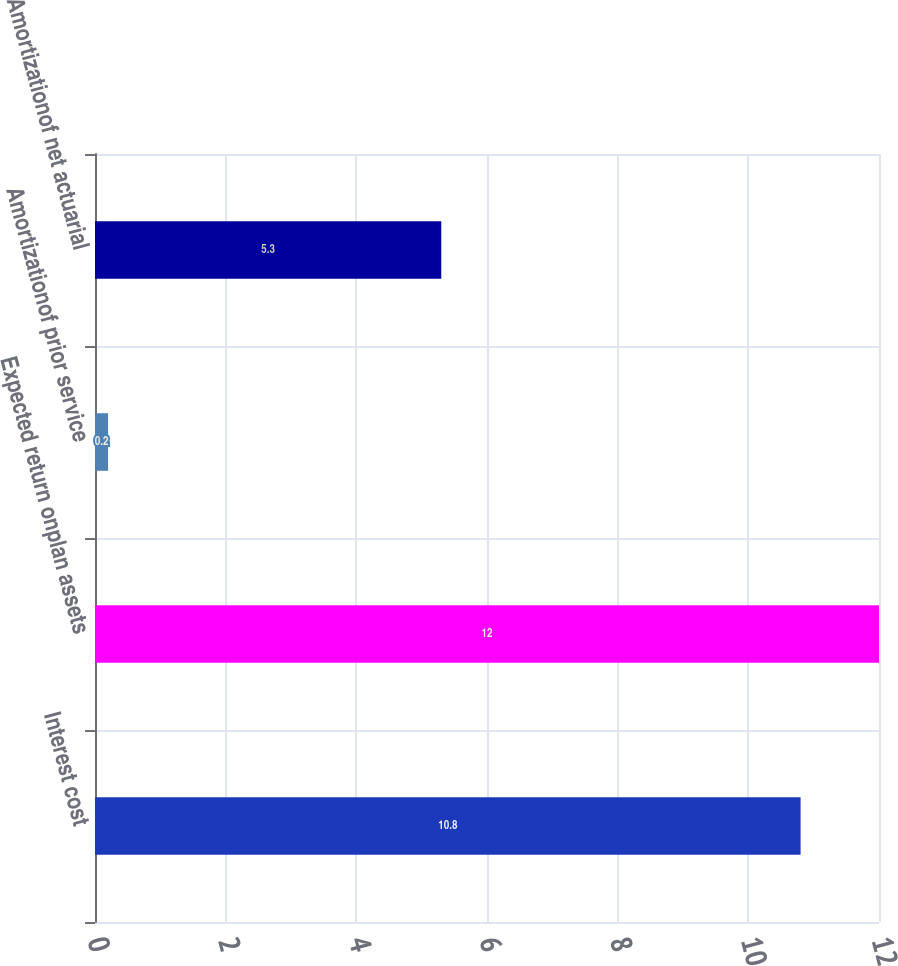Convert chart to OTSL. <chart><loc_0><loc_0><loc_500><loc_500><bar_chart><fcel>Interest cost<fcel>Expected return onplan assets<fcel>Amortizationof prior service<fcel>Amortizationof net actuarial<nl><fcel>10.8<fcel>12<fcel>0.2<fcel>5.3<nl></chart> 